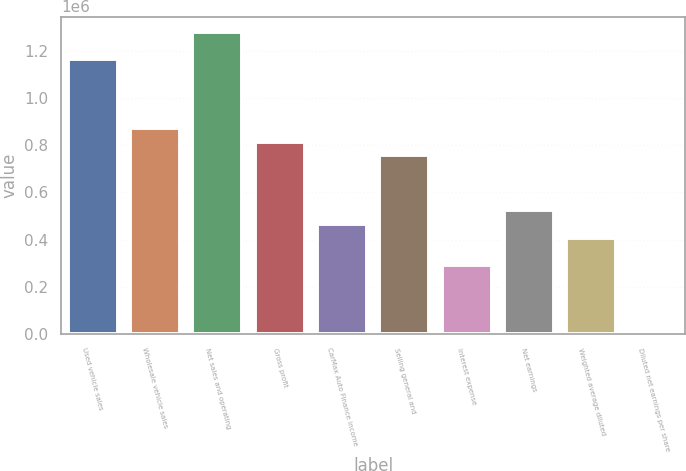<chart> <loc_0><loc_0><loc_500><loc_500><bar_chart><fcel>Used vehicle sales<fcel>Wholesale vehicle sales<fcel>Net sales and operating<fcel>Gross profit<fcel>CarMax Auto Finance income<fcel>Selling general and<fcel>Interest expense<fcel>Net earnings<fcel>Weighted average diluted<fcel>Diluted net earnings per share<nl><fcel>1.16456e+06<fcel>873422<fcel>1.28102e+06<fcel>815194<fcel>465826<fcel>756966<fcel>291142<fcel>524054<fcel>407598<fcel>2.73<nl></chart> 